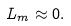<formula> <loc_0><loc_0><loc_500><loc_500>L _ { m } \approx 0 .</formula> 